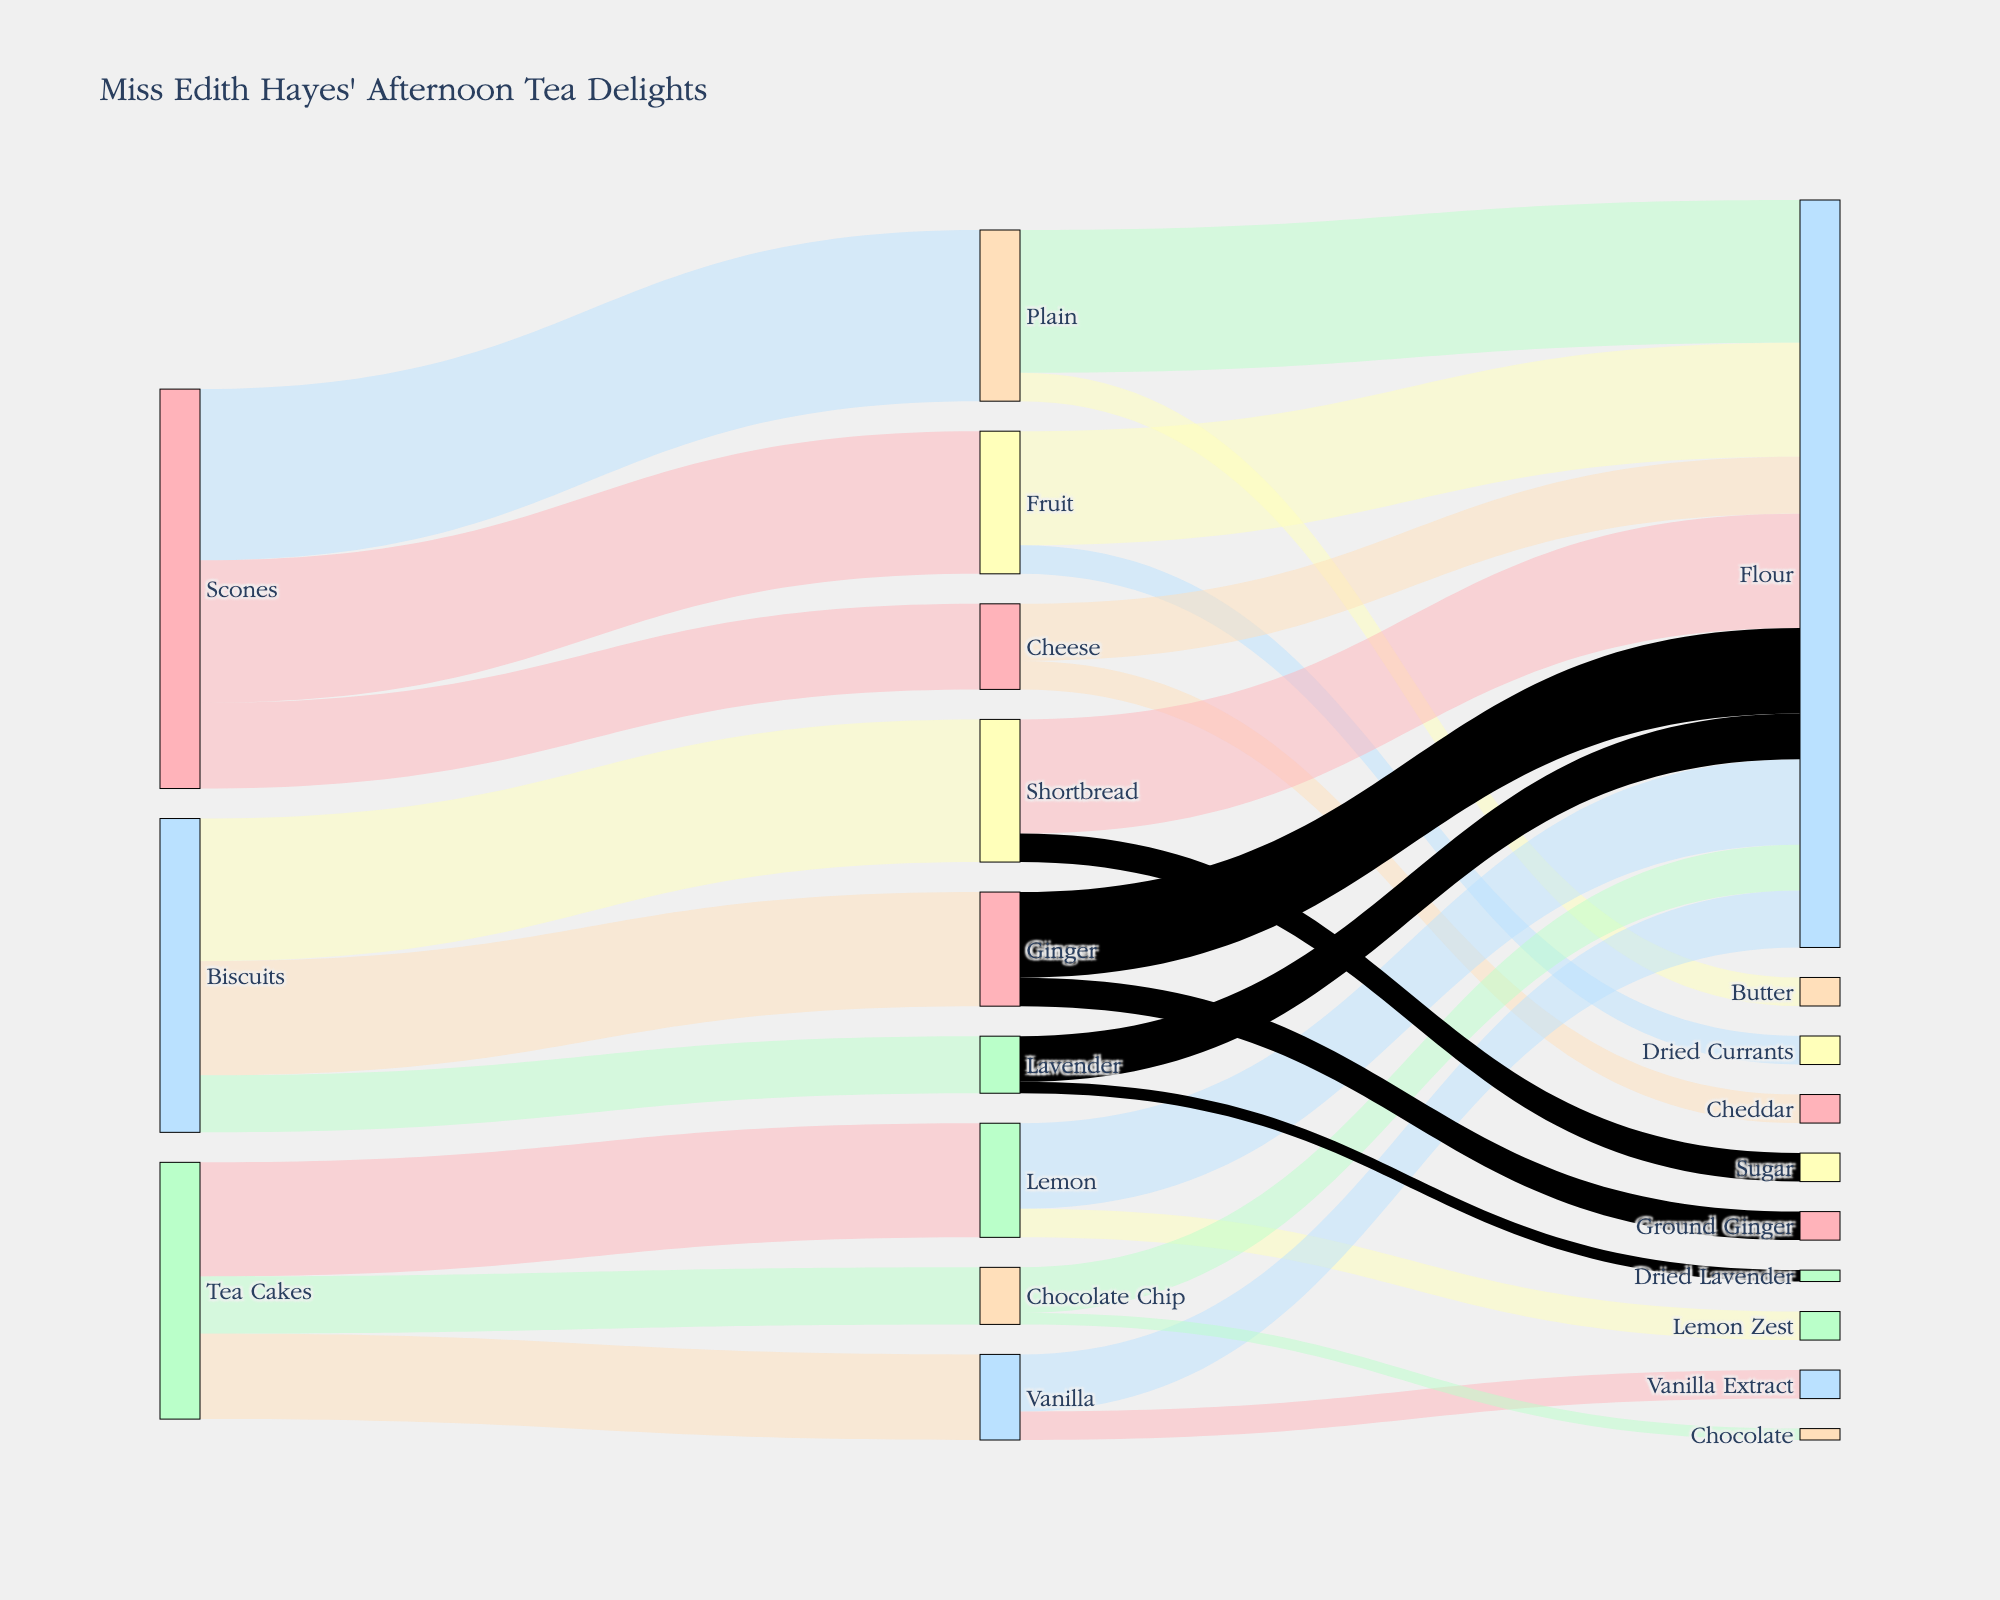Which type of baked good has the highest total number of servings? By looking at the diagram, we see that Scones have three flow paths (Plain, Fruit, Cheese) with values of 30, 25, and 15, summing up to 70. Tea Cakes total to 45 (Lemon, Vanilla, Chocolate Chip), and Biscuits total to 55 (Shortbread, Ginger, Lavender). Thus, Scones have the highest total number of servings.
Answer: Scones What is the total amount of flour used across all baked goods for afternoon tea? Adding up all the flows that go into "Flour": Scones (25+20+10), Tea Cakes (15+10+8), Biscuits (20+15+8) gives the total. 55+33+43 gives us a total of 121.
Answer: 121 Which baked good uses the most unique types of ingredients? By observing the flows, Scones have three unique ingredients (Flour, Butter, Dried Currants, Cheddar), Tea Cakes have four (Flour, Lemon Zest, Vanilla Extract, Chocolate), and Biscuits have three (Flour, Sugar, Ground Ginger, Dried Lavender). Tea Cakes use the most unique types of ingredients.
Answer: Tea Cakes If you sum up the servings of Plain and Fruit scones, what proportion of the total scone servings does it represent? Plain and Fruit Scones have 30 and 25 servings, respectively, summing to 55. The total number of Scones servings is 70. The proportion is thus 55/70, which is approximately 0.786 or 78.6%.
Answer: 78.6% Which flavor of Tea Cakes is the least served? Observing the flow values for Tea Cakes, Lemon has 20, Vanilla has 15, and Chocolate Chip has 10. Chocolate Chip has the least servings.
Answer: Chocolate Chip How many distinct ingredient types are used in making the Biscuits? Observing the flow paths for Biscuits, the following unique ingredients are used: Flour, Sugar, Ground Ginger, Dried Lavender. That is a total of 4 distinct ingredient types.
Answer: 4 Compare the amount of sugar used in Shortbread biscuits to the amount of butter used in Plain scones. Which is greater, and by how much? For Shortbread, 5 units of Sugar. For Plain Scones, 5 units of Butter. Both are equal, hence the difference is 0.
Answer: Equal, 0 What is the predominant ingredient used in Cheese scones? Observing the flow to Cheese Scones, Flour is used 10 times while Cheddar is used 5 times. Therefore, Flour is the predominant ingredient.
Answer: Flour How many different colors are used in the diagram? By inspecting the unique colors mentioned, there is a total of 10 different color codes applied in the Sankey diagram.
Answer: 10 Which ingredient appears in all three types of baked goods (Scones, Tea Cakes, and Biscuits)? By tracing the flow paths originating from each baked good, we can see that Flour is the ingredient that appears in all three baked goods.
Answer: Flour 